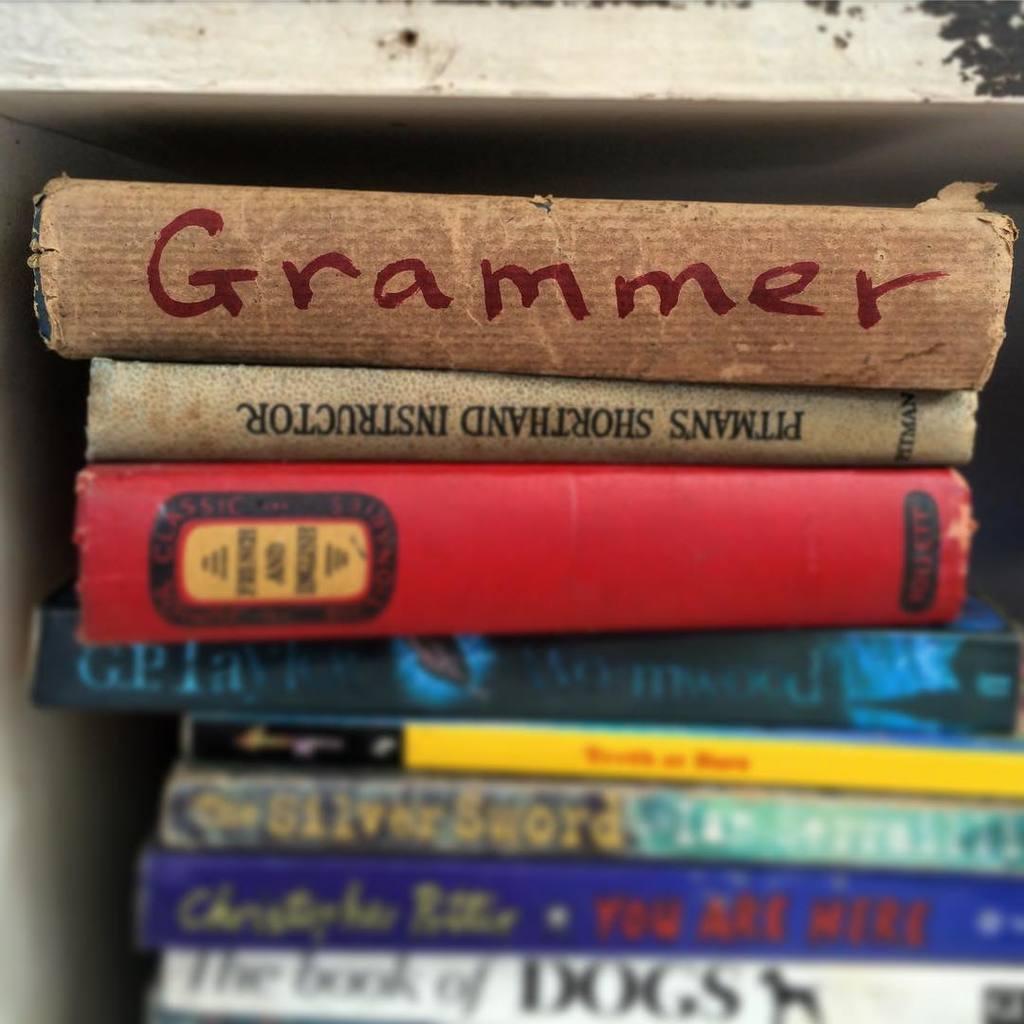What is the name of the book on top of the stack?
Provide a short and direct response. Grammer. What is the title of the white book on the bottom of the stack?
Offer a terse response. The book of dogs. 